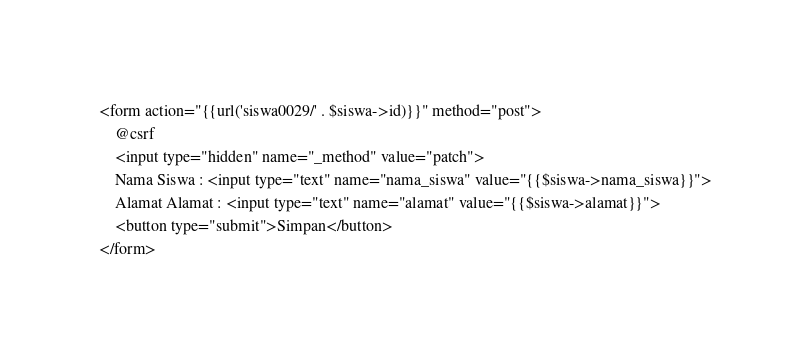<code> <loc_0><loc_0><loc_500><loc_500><_PHP_><form action="{{url('siswa0029/' . $siswa->id)}}" method="post">
    @csrf
    <input type="hidden" name="_method" value="patch">
    Nama Siswa : <input type="text" name="nama_siswa" value="{{$siswa->nama_siswa}}">
    Alamat Alamat : <input type="text" name="alamat" value="{{$siswa->alamat}}">
    <button type="submit">Simpan</button>
</form></code> 